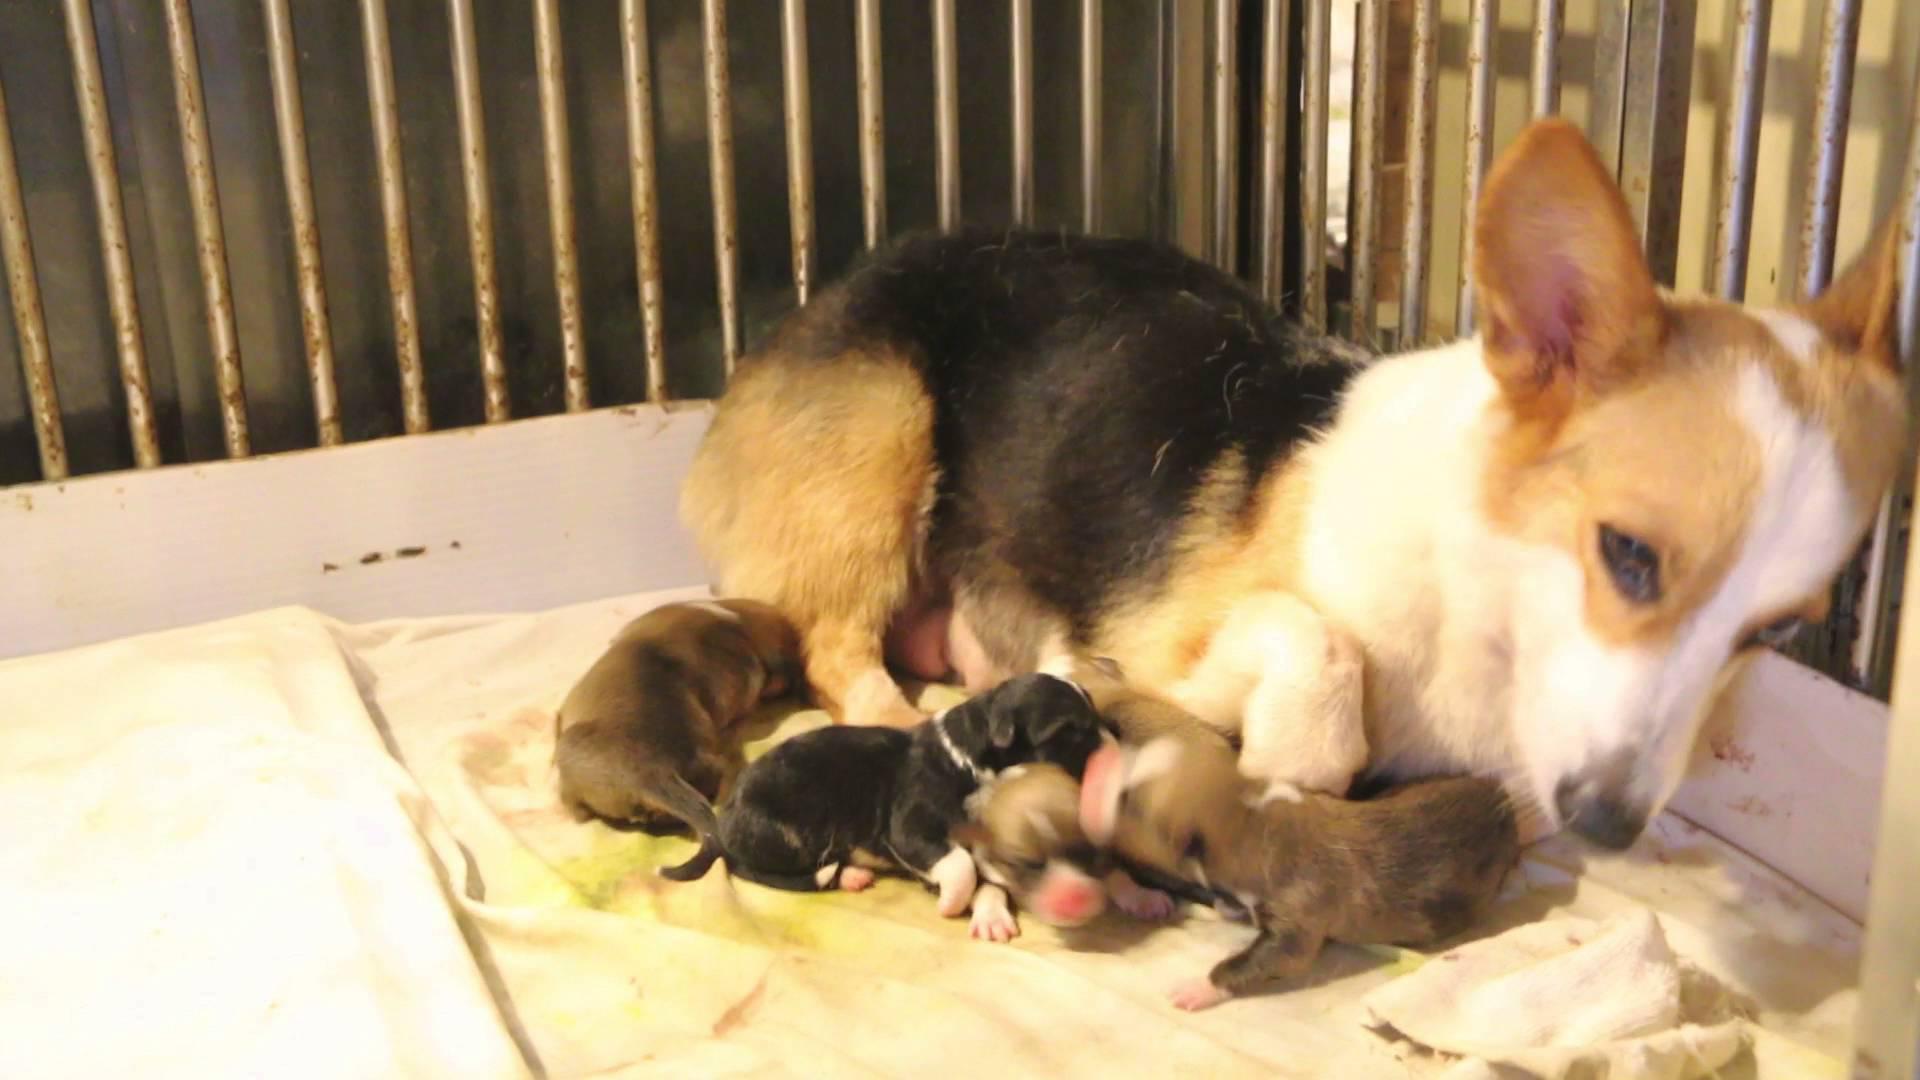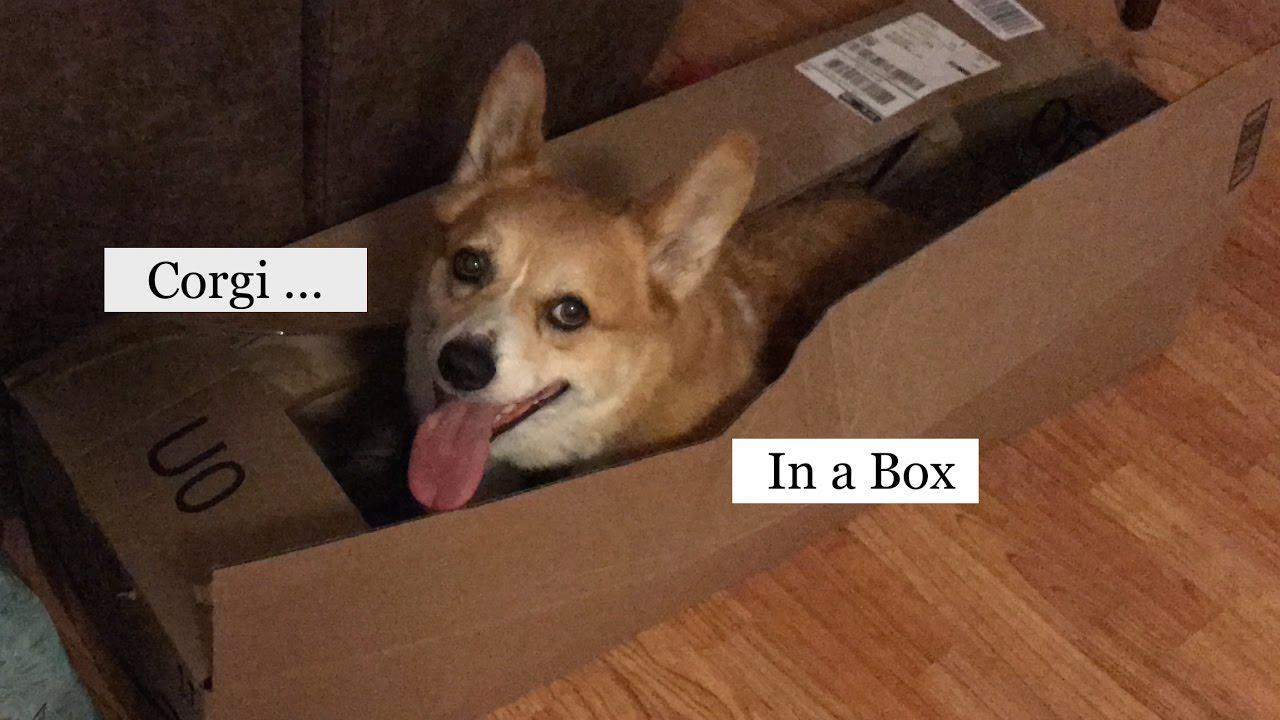The first image is the image on the left, the second image is the image on the right. Given the left and right images, does the statement "A dog is in a brown cardboard box with its flaps folding outward instead of tucked inward." hold true? Answer yes or no. No. The first image is the image on the left, the second image is the image on the right. Examine the images to the left and right. Is the description "There are two adult corgis, one of which is clearly in a box." accurate? Answer yes or no. Yes. 